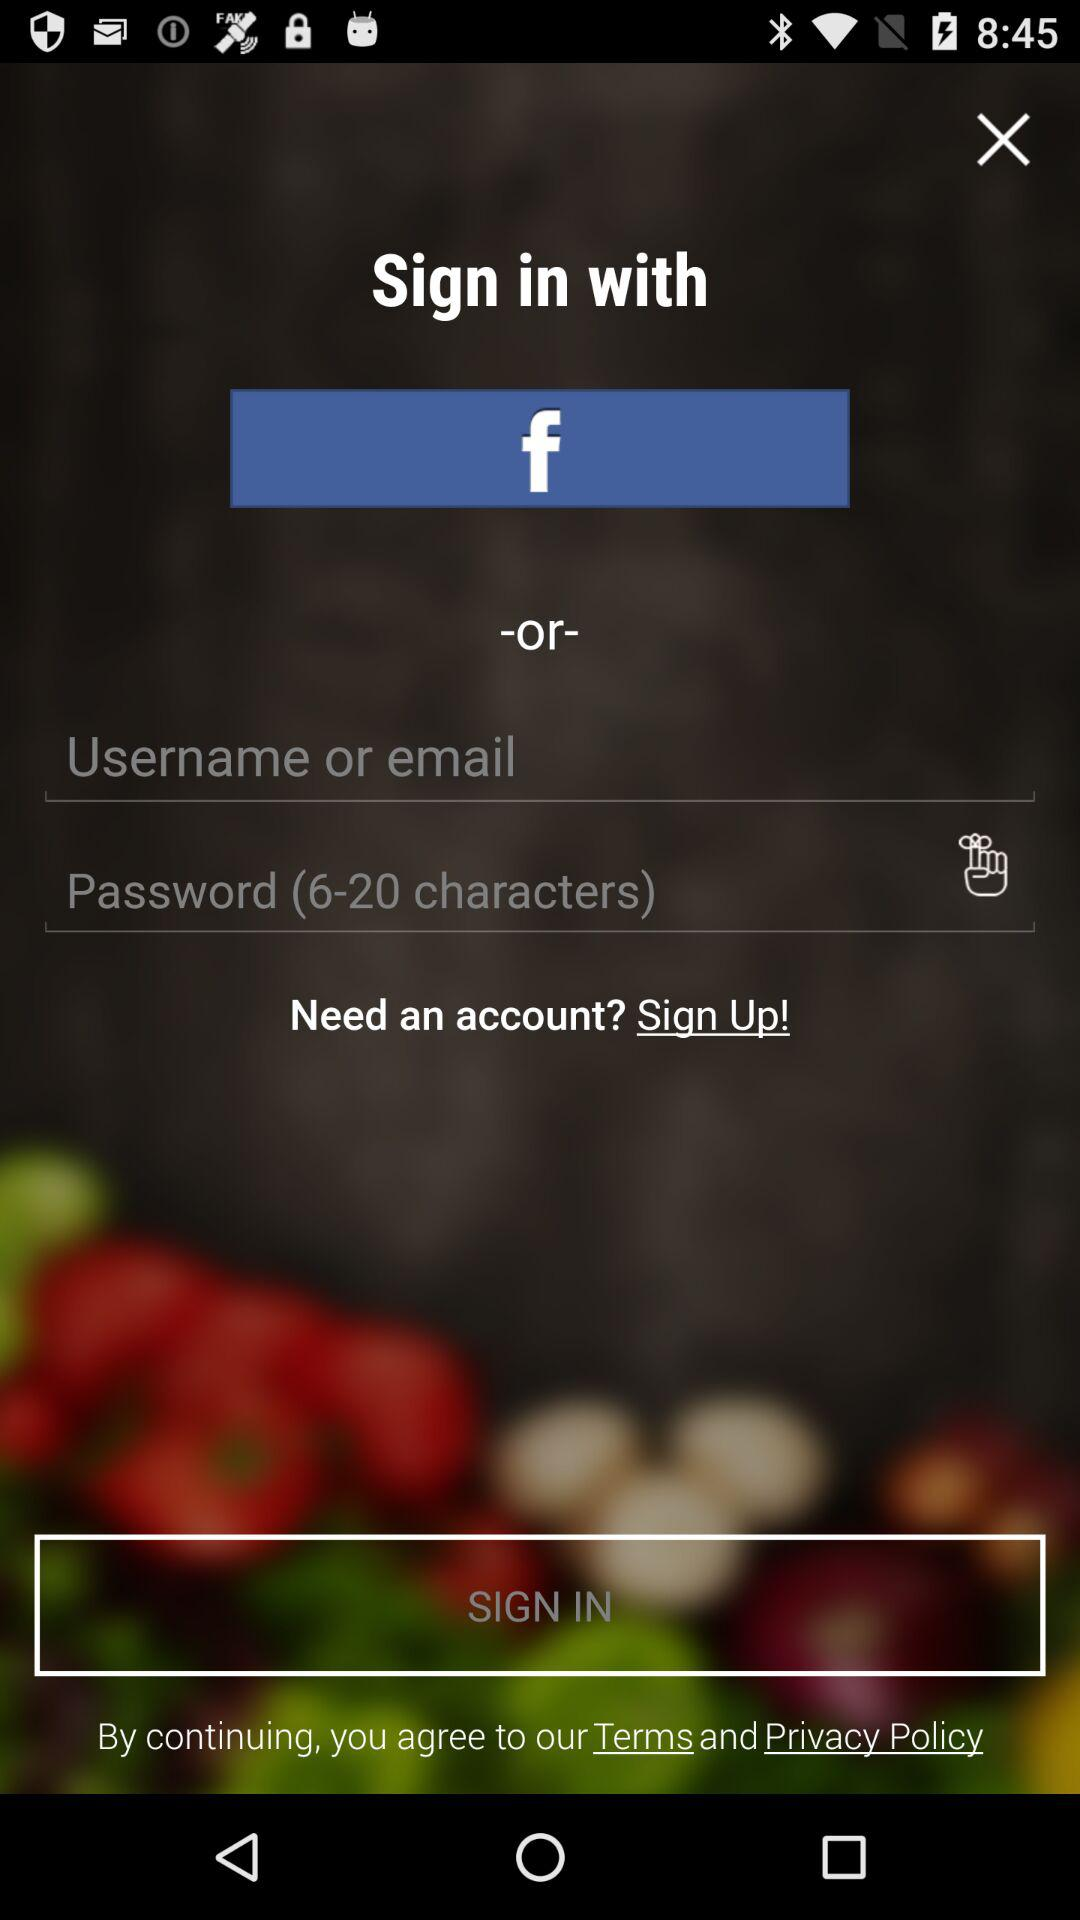Which social media option is given to sign up with? The given social media option to sign up with is "Facebook". 